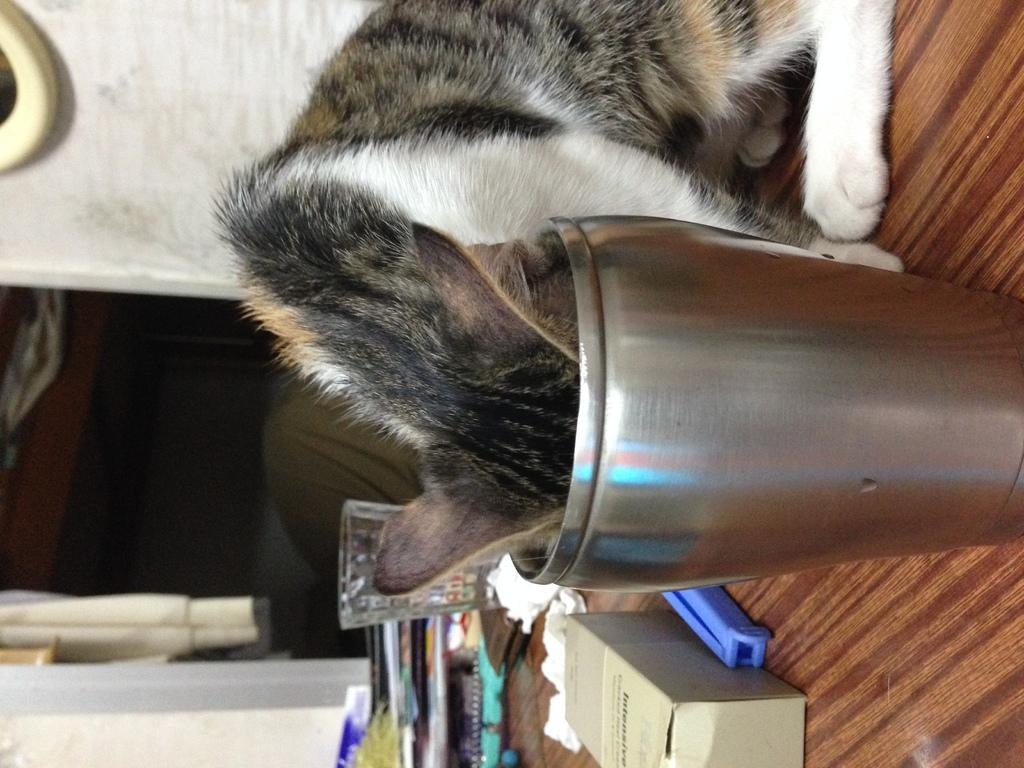What is the main object in the image? The main object in the image is a table. What is on the table? There is a cat, a steel object, a glass, a box, and some unspecified items on the table. What can be seen in the background of the image? There is a wall visible in the background, and there are blurred objects in the background. What country is the cat from, as depicted in the image? The image does not provide any information about the cat's country of origin. What type of lace can be seen on the table in the image? There is no lace present on the table in the image. 